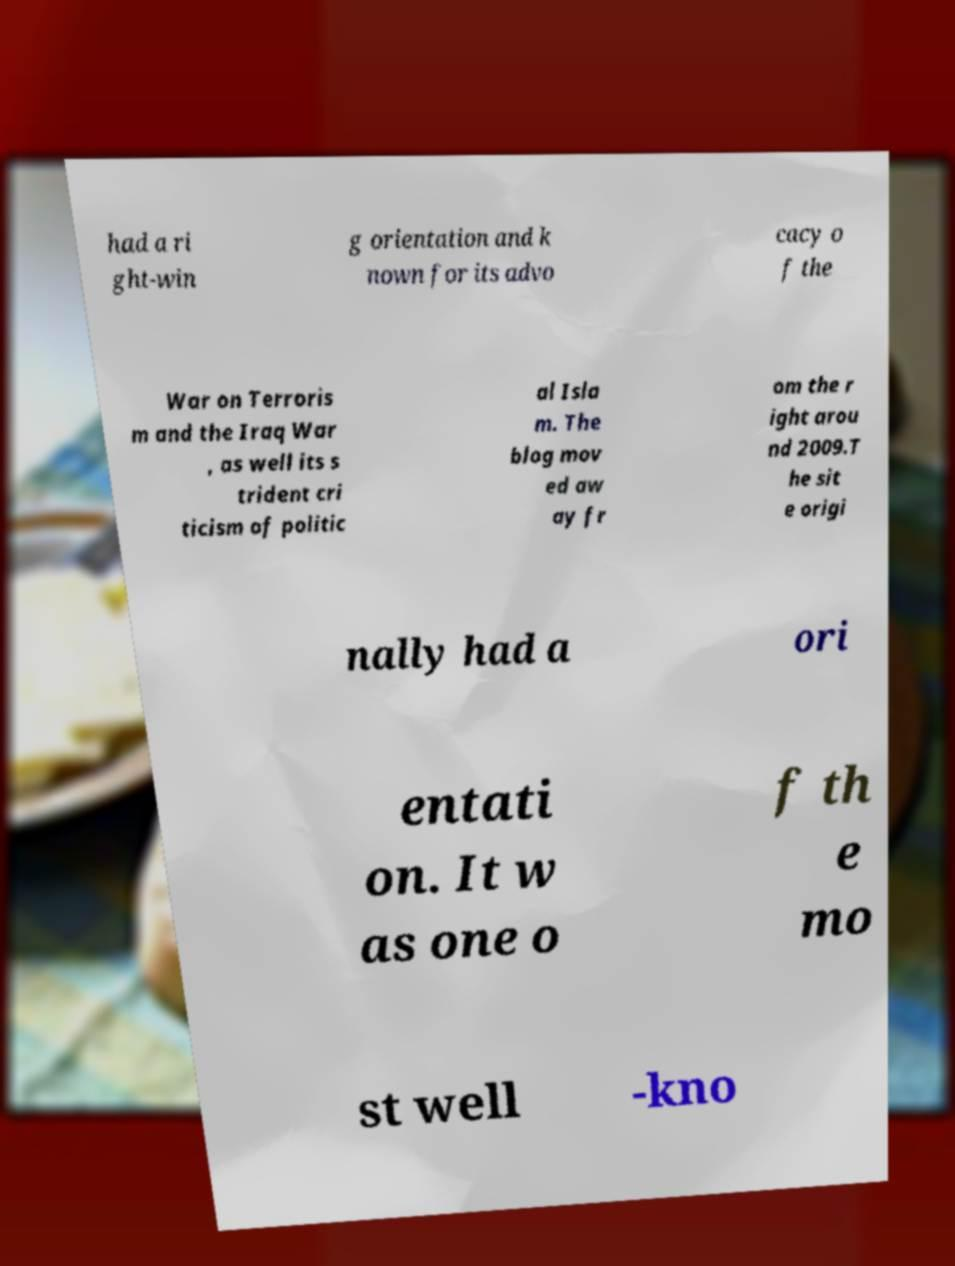There's text embedded in this image that I need extracted. Can you transcribe it verbatim? had a ri ght-win g orientation and k nown for its advo cacy o f the War on Terroris m and the Iraq War , as well its s trident cri ticism of politic al Isla m. The blog mov ed aw ay fr om the r ight arou nd 2009.T he sit e origi nally had a ori entati on. It w as one o f th e mo st well -kno 